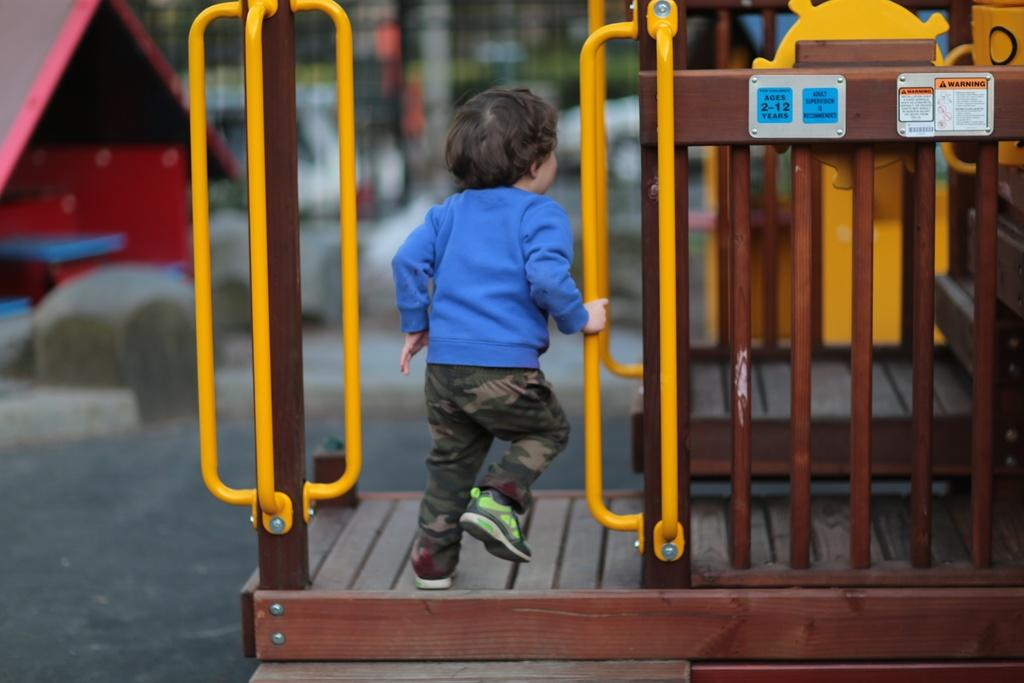What is the main subject of the image? The main subject of the image is a kid. Where is the kid located in the image? The kid is standing near an outdoor playground. Can you describe the background of the image? The background of the image is blurred. What type of magic is the kid performing in the image? There is no indication of magic or any magical activity in the image. 